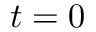<formula> <loc_0><loc_0><loc_500><loc_500>t = 0</formula> 